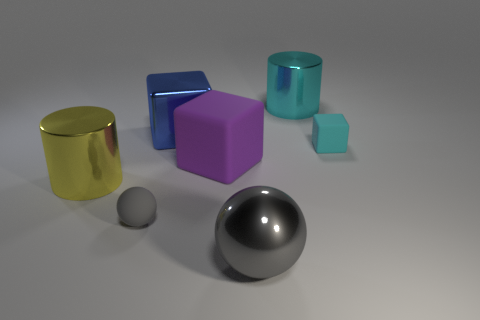Subtract all big blocks. How many blocks are left? 1 Subtract all cyan cylinders. How many cylinders are left? 1 Subtract all cylinders. How many objects are left? 5 Add 2 big red objects. How many objects exist? 9 Subtract 2 spheres. How many spheres are left? 0 Subtract 0 cyan balls. How many objects are left? 7 Subtract all purple spheres. Subtract all cyan cubes. How many spheres are left? 2 Subtract all big gray shiny objects. Subtract all big purple spheres. How many objects are left? 6 Add 1 small rubber balls. How many small rubber balls are left? 2 Add 5 big cyan metallic things. How many big cyan metallic things exist? 6 